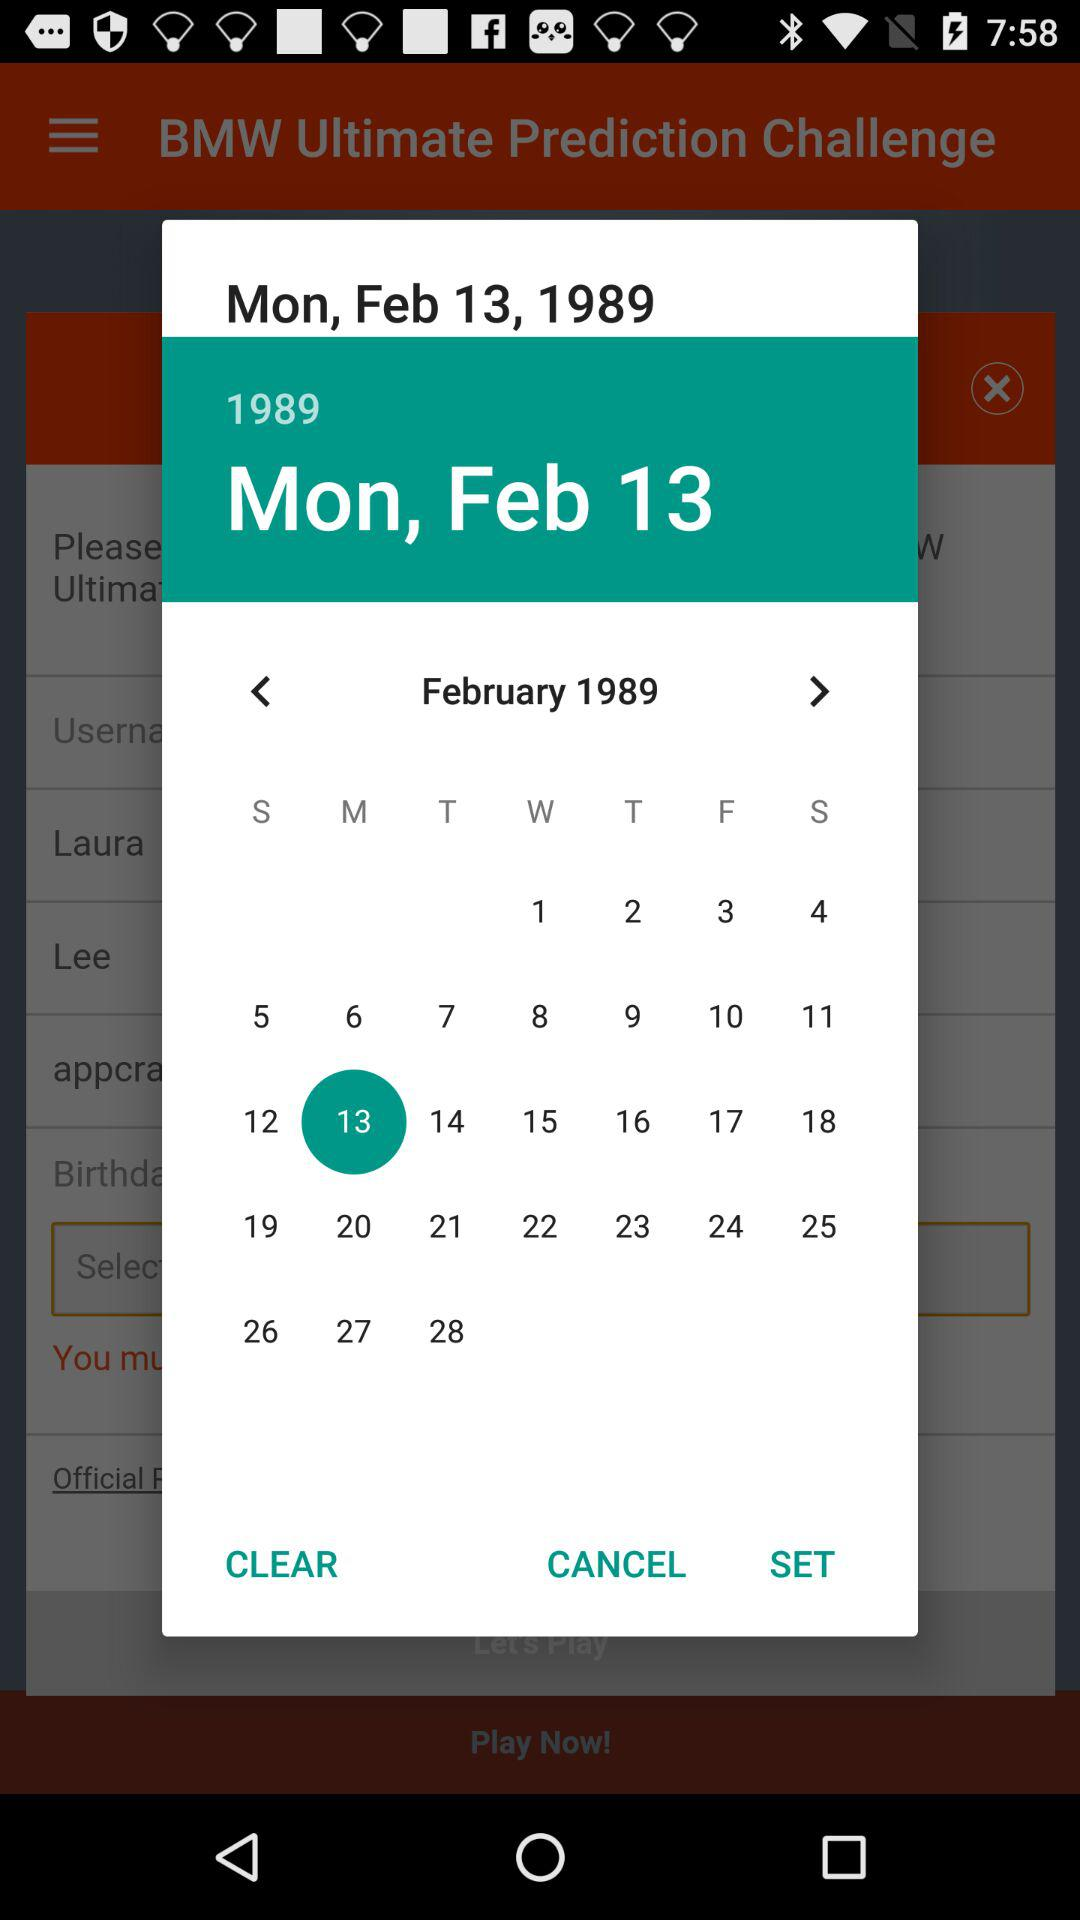What is the selected date? The selected date is Monday, February 13, 1989. 